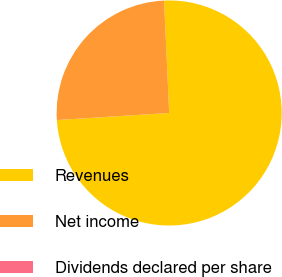Convert chart to OTSL. <chart><loc_0><loc_0><loc_500><loc_500><pie_chart><fcel>Revenues<fcel>Net income<fcel>Dividends declared per share<nl><fcel>74.72%<fcel>25.28%<fcel>0.0%<nl></chart> 